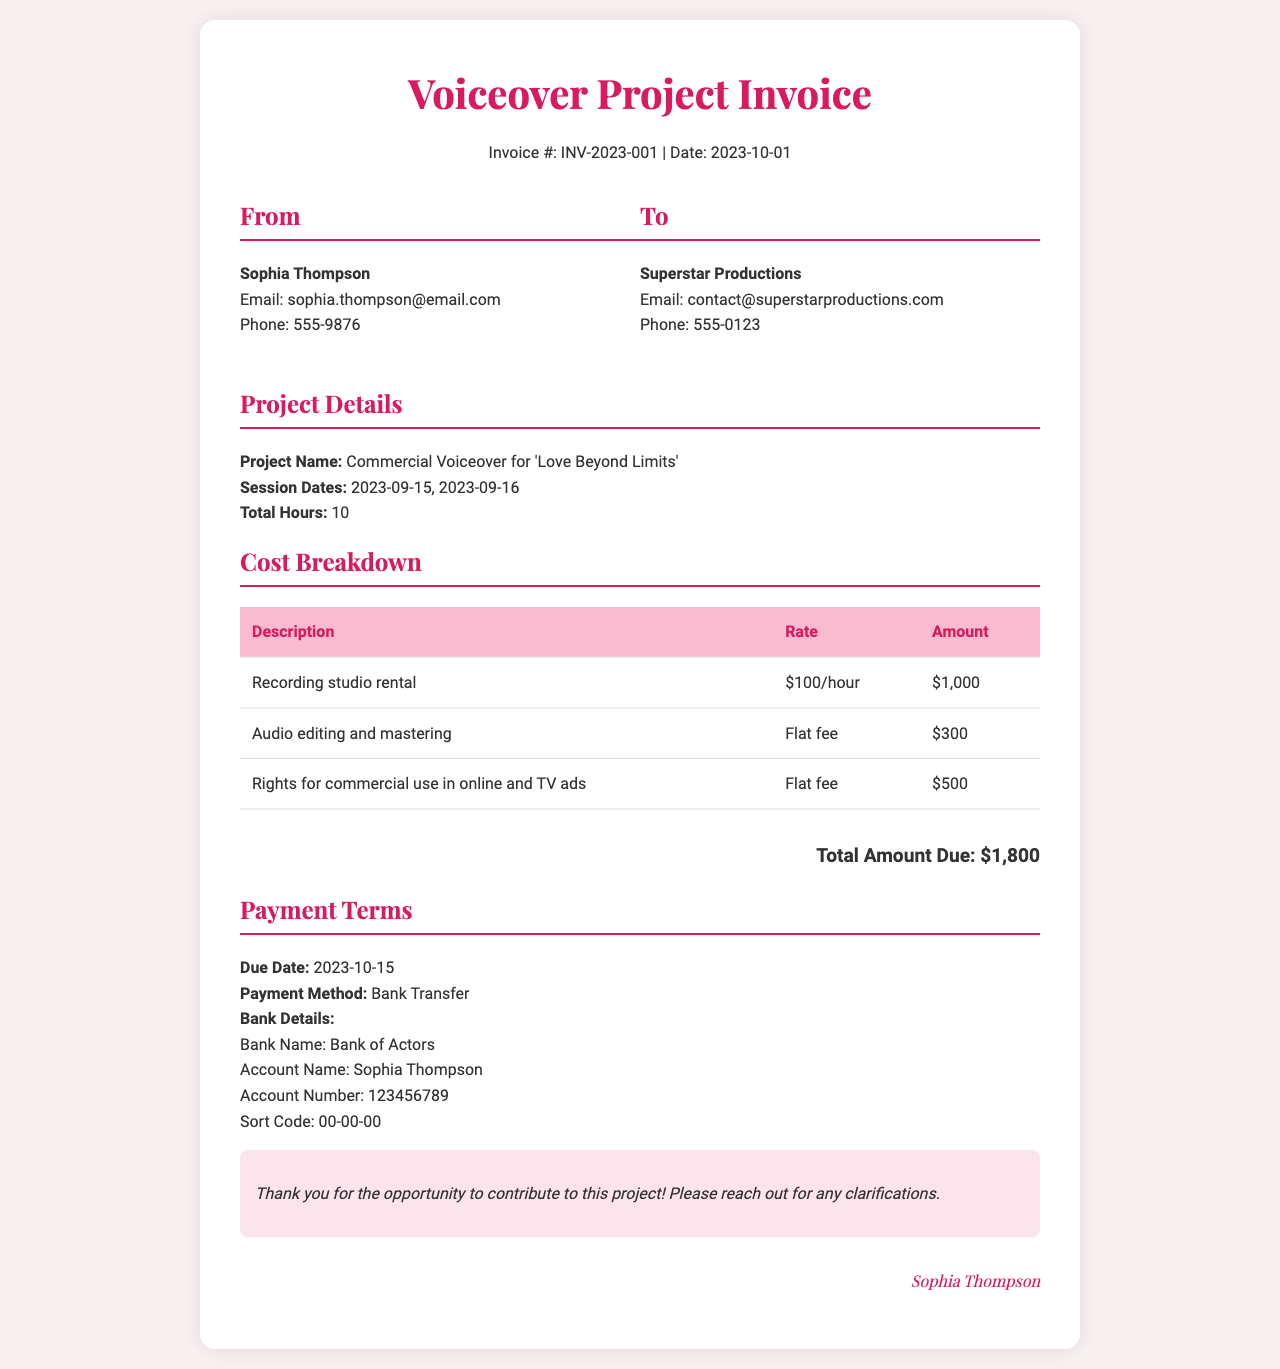What is the invoice number? The invoice number is specified in the document header, marked as INV-2023-001.
Answer: INV-2023-001 Who is the sender of the invoice? The sender's information is provided under the "From" section, stating Sophia Thompson.
Answer: Sophia Thompson What is the total amount due? The total amount due is at the bottom of the invoice, listed as $1,800.
Answer: $1,800 What are the session dates for the project? The session dates are indicated in the project details section, specifically mentioned as 2023-09-15 and 2023-09-16.
Answer: 2023-09-15, 2023-09-16 What is the rate for the recording studio rental? The rate for the recording studio rental is found in the cost breakdown, noted as $100/hour.
Answer: $100/hour How much is charged for audio editing and mastering? The charge for audio editing and mastering is provided as a flat fee in the cost breakdown.
Answer: $300 What is the payment due date? The payment due date is specified in the payment terms section as 2023-10-15.
Answer: 2023-10-15 What payment method is accepted? The accepted payment method is stated in the payment terms under "Payment Method."
Answer: Bank Transfer What type of rights are included in the invoice? The rights included are mentioned in the cost breakdown as rights for commercial use in online and TV ads.
Answer: Rights for commercial use in online and TV ads 